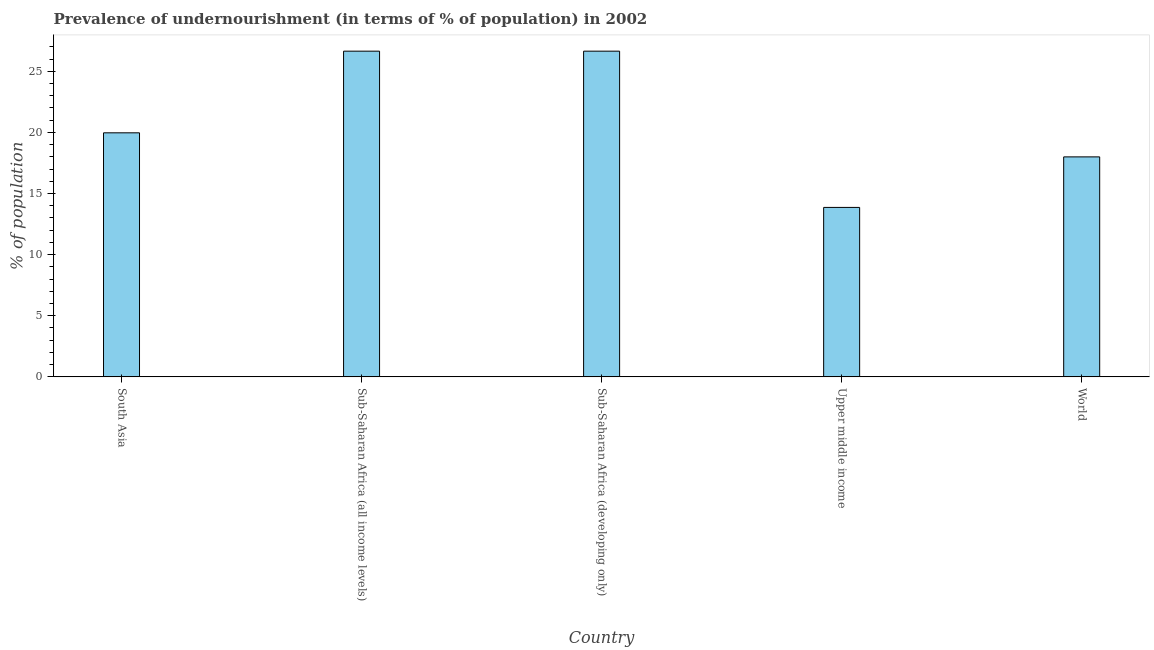What is the title of the graph?
Make the answer very short. Prevalence of undernourishment (in terms of % of population) in 2002. What is the label or title of the X-axis?
Make the answer very short. Country. What is the label or title of the Y-axis?
Your answer should be very brief. % of population. What is the percentage of undernourished population in Upper middle income?
Your answer should be very brief. 13.86. Across all countries, what is the maximum percentage of undernourished population?
Your answer should be very brief. 26.65. Across all countries, what is the minimum percentage of undernourished population?
Your response must be concise. 13.86. In which country was the percentage of undernourished population maximum?
Give a very brief answer. Sub-Saharan Africa (all income levels). In which country was the percentage of undernourished population minimum?
Your answer should be very brief. Upper middle income. What is the sum of the percentage of undernourished population?
Give a very brief answer. 105.12. What is the difference between the percentage of undernourished population in Upper middle income and World?
Make the answer very short. -4.13. What is the average percentage of undernourished population per country?
Make the answer very short. 21.02. What is the median percentage of undernourished population?
Make the answer very short. 19.97. What is the ratio of the percentage of undernourished population in South Asia to that in Sub-Saharan Africa (developing only)?
Provide a short and direct response. 0.75. Is the sum of the percentage of undernourished population in Upper middle income and World greater than the maximum percentage of undernourished population across all countries?
Your answer should be compact. Yes. What is the difference between the highest and the lowest percentage of undernourished population?
Offer a very short reply. 12.78. In how many countries, is the percentage of undernourished population greater than the average percentage of undernourished population taken over all countries?
Make the answer very short. 2. How many bars are there?
Provide a succinct answer. 5. Are all the bars in the graph horizontal?
Provide a short and direct response. No. What is the difference between two consecutive major ticks on the Y-axis?
Give a very brief answer. 5. Are the values on the major ticks of Y-axis written in scientific E-notation?
Provide a succinct answer. No. What is the % of population in South Asia?
Offer a terse response. 19.97. What is the % of population of Sub-Saharan Africa (all income levels)?
Ensure brevity in your answer.  26.65. What is the % of population in Sub-Saharan Africa (developing only)?
Offer a very short reply. 26.65. What is the % of population in Upper middle income?
Provide a short and direct response. 13.86. What is the % of population of World?
Provide a short and direct response. 18. What is the difference between the % of population in South Asia and Sub-Saharan Africa (all income levels)?
Your response must be concise. -6.68. What is the difference between the % of population in South Asia and Sub-Saharan Africa (developing only)?
Ensure brevity in your answer.  -6.68. What is the difference between the % of population in South Asia and Upper middle income?
Give a very brief answer. 6.1. What is the difference between the % of population in South Asia and World?
Keep it short and to the point. 1.97. What is the difference between the % of population in Sub-Saharan Africa (all income levels) and Sub-Saharan Africa (developing only)?
Provide a succinct answer. 0. What is the difference between the % of population in Sub-Saharan Africa (all income levels) and Upper middle income?
Keep it short and to the point. 12.78. What is the difference between the % of population in Sub-Saharan Africa (all income levels) and World?
Offer a terse response. 8.65. What is the difference between the % of population in Sub-Saharan Africa (developing only) and Upper middle income?
Make the answer very short. 12.78. What is the difference between the % of population in Sub-Saharan Africa (developing only) and World?
Ensure brevity in your answer.  8.65. What is the difference between the % of population in Upper middle income and World?
Offer a very short reply. -4.13. What is the ratio of the % of population in South Asia to that in Sub-Saharan Africa (all income levels)?
Ensure brevity in your answer.  0.75. What is the ratio of the % of population in South Asia to that in Sub-Saharan Africa (developing only)?
Offer a terse response. 0.75. What is the ratio of the % of population in South Asia to that in Upper middle income?
Ensure brevity in your answer.  1.44. What is the ratio of the % of population in South Asia to that in World?
Provide a short and direct response. 1.11. What is the ratio of the % of population in Sub-Saharan Africa (all income levels) to that in Sub-Saharan Africa (developing only)?
Provide a succinct answer. 1. What is the ratio of the % of population in Sub-Saharan Africa (all income levels) to that in Upper middle income?
Make the answer very short. 1.92. What is the ratio of the % of population in Sub-Saharan Africa (all income levels) to that in World?
Offer a terse response. 1.48. What is the ratio of the % of population in Sub-Saharan Africa (developing only) to that in Upper middle income?
Ensure brevity in your answer.  1.92. What is the ratio of the % of population in Sub-Saharan Africa (developing only) to that in World?
Ensure brevity in your answer.  1.48. What is the ratio of the % of population in Upper middle income to that in World?
Your answer should be compact. 0.77. 